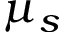<formula> <loc_0><loc_0><loc_500><loc_500>\mu _ { s }</formula> 